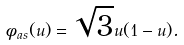Convert formula to latex. <formula><loc_0><loc_0><loc_500><loc_500>\phi _ { a s } ( u ) = \sqrt { 3 } u ( 1 - u ) .</formula> 